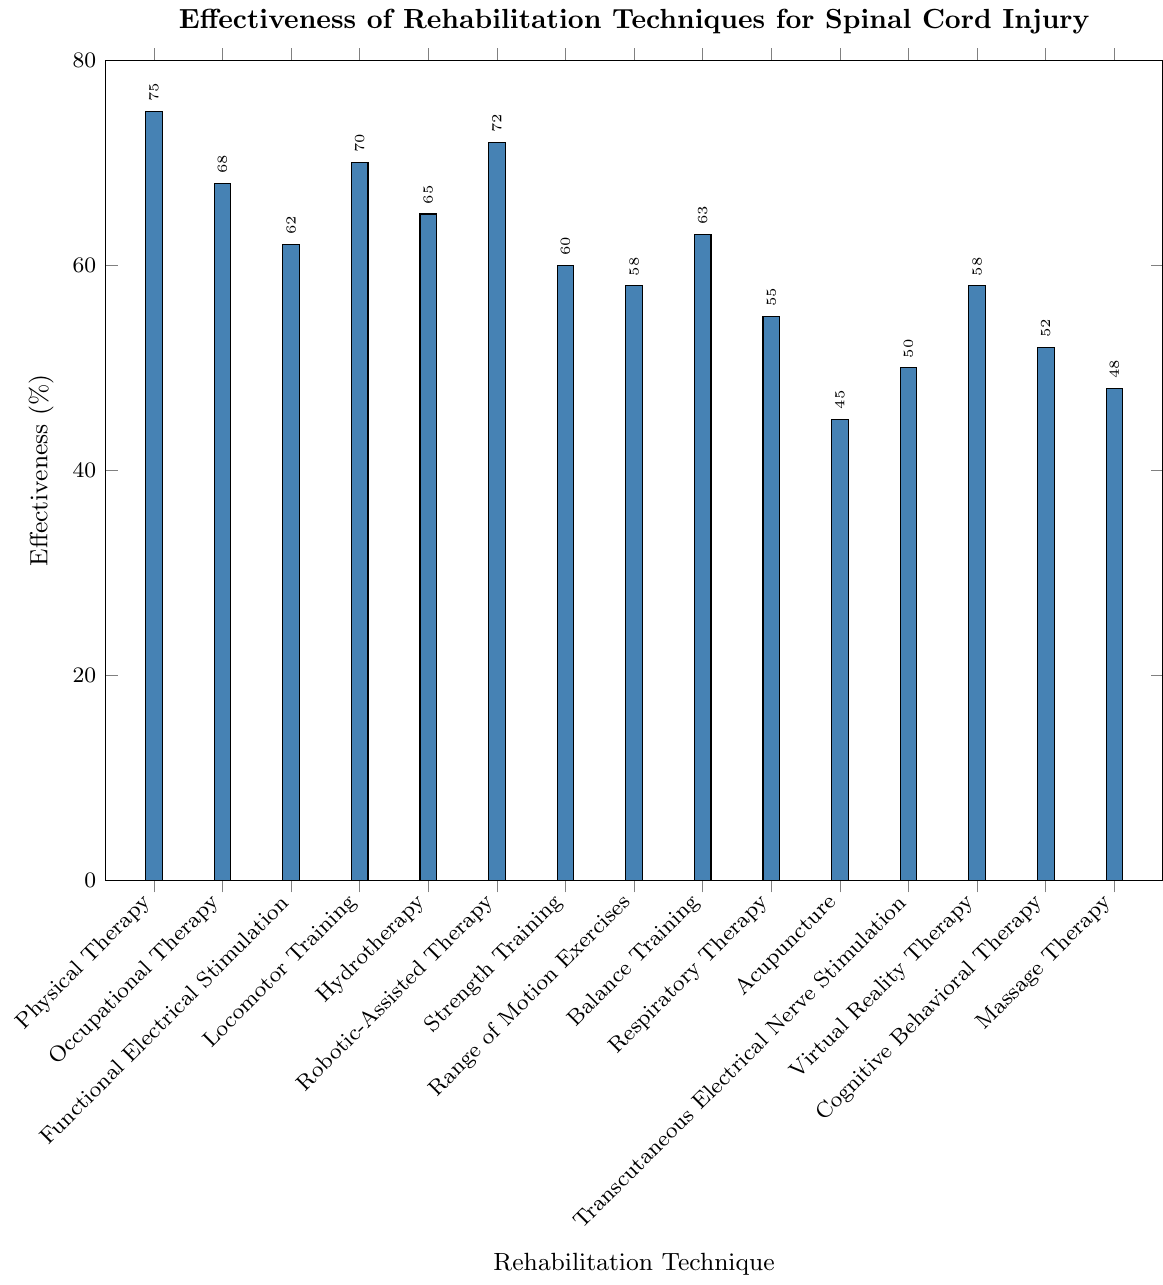What's the most effective rehabilitation technique for spinal cord injury patients? By looking at the heights of the bars in the chart, the tallest bar represents the most effective technique. The tallest bar corresponds to Physical Therapy with an effectiveness of 75%.
Answer: Physical Therapy Which rehabilitation technique has an effectiveness of 60%? Locate the bar that reaches up to the 60% mark. The label directly below this bar indicates which technique it represents. The corresponding technique is Strength Training.
Answer: Strength Training Compare the effectiveness of Hydrotherapy and Virtual Reality Therapy. Which one is more effective and by how much? Locate the bars for Hydrotherapy and Virtual Reality Therapy on the x-axis. Hydrotherapy has an effectiveness of 65% and Virtual Reality Therapy has 58%. Calculate the difference: 65% - 58% = 7%.
Answer: Hydrotherapy by 7% What is the average effectiveness of Physical Therapy, Occupational Therapy, and Robotic-Assisted Therapy? Find the effectiveness percentages of the three techniques: Physical Therapy (75%), Occupational Therapy (68%), and Robotic-Assisted Therapy (72%). Calculate the average: (75 + 68 + 72) / 3 = 71.7%.
Answer: 71.7% Which rehabilitation technique is least effective, and what is its effectiveness percentage? The shortest bar in the plot indicates the least effective technique. This bar corresponds to Acupuncture with an effectiveness of 45%.
Answer: Acupuncture, 45% What's the difference in effectiveness between the most and least effective techniques? Identify the most effective technique (Physical Therapy: 75%) and the least effective technique (Acupuncture: 45%). Calculate the difference: 75% - 45% = 30%.
Answer: 30% How many techniques have an effectiveness above 60%? Count the number of bars with heights above the 60% mark. These are Physical Therapy, Occupational Therapy, Functional Electrical Stimulation, Locomotor Training, Hydrotherapy, Robotic-Assisted Therapy, and Balance Training. There are 7 such techniques.
Answer: 7 If you were to combine the effectiveness of Occupational Therapy and Locomotor Training, what would be the total percentage? Find the effectiveness percentages of Occupational Therapy (68%) and Locomotor Training (70%). Sum them up: 68% + 70% = 138%.
Answer: 138% 